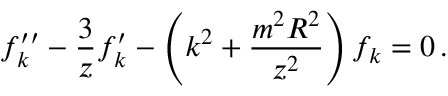Convert formula to latex. <formula><loc_0><loc_0><loc_500><loc_500>f _ { k } ^ { \prime \prime } - { \frac { 3 } { z } } f _ { k } ^ { \prime } - \left ( k ^ { 2 } + { \frac { m ^ { 2 } R ^ { 2 } } { z ^ { 2 } } } \right ) f _ { k } = 0 \, .</formula> 